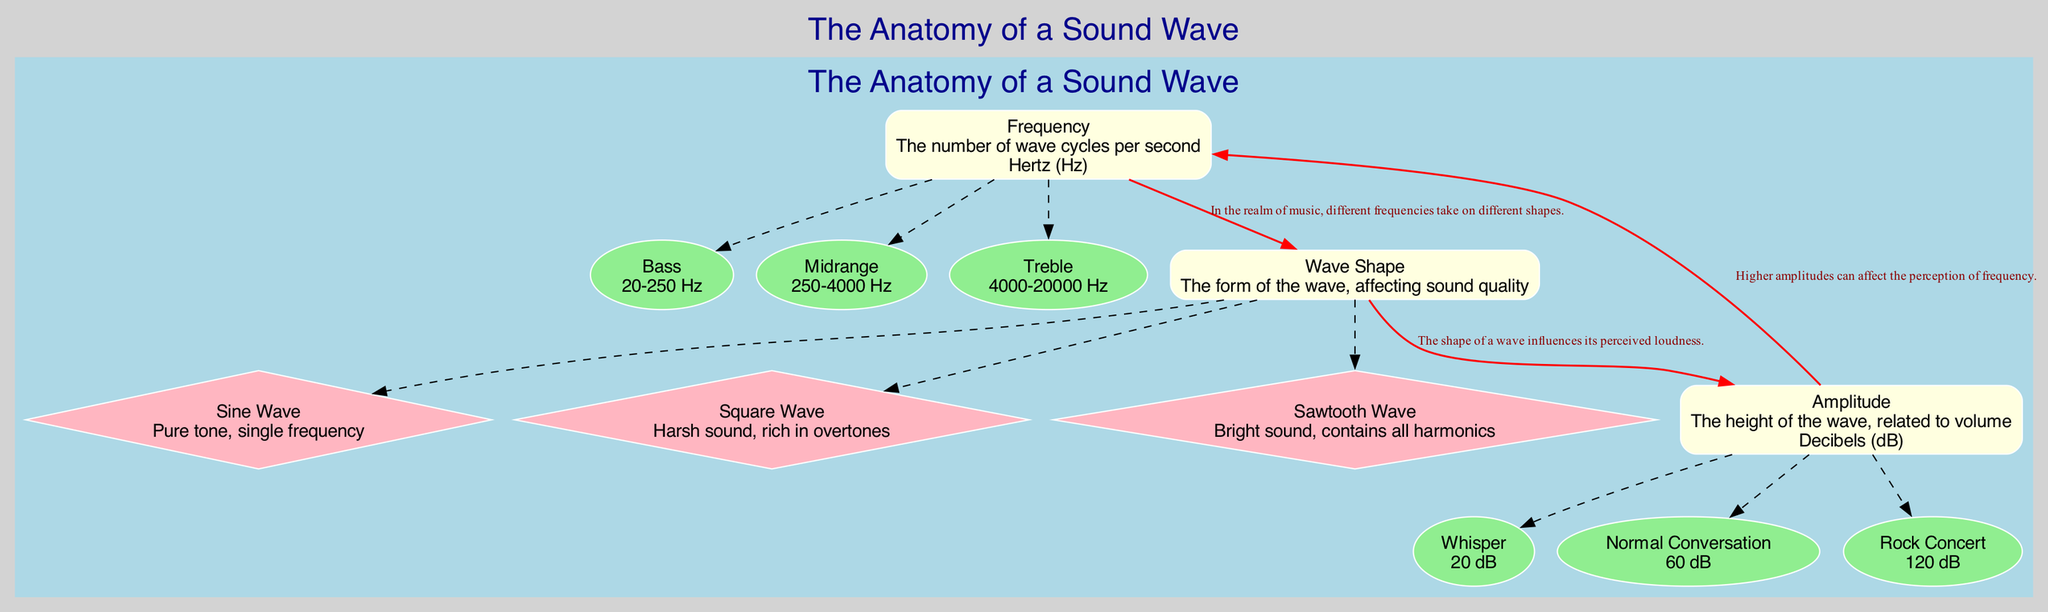What is the unit for frequency? The diagram indicates that frequency is measured in Hertz (Hz). It is clearly stated within the "Frequency" node description in the diagram.
Answer: Hertz (Hz) What is the amplitude of a rock concert? The diagram shows that a rock concert has an amplitude of 120 decibels (dB), as indicated in the "Examples" section under "Amplitude."
Answer: 120 dB How many types of wave shapes are listed? The diagram specifies three types of wave shapes: Sine Wave, Square Wave, and Sawtooth Wave. This information is presented under the "Wave Shape" component in the diagram.
Answer: Three What relationship is indicated between frequency and wave shape? The diagram describes that different frequencies take on different shapes, indicating a relationship of transformation between frequency and wave shape. This is clearly labeled within the edge connecting the two nodes.
Answer: Different shapes Which sound wave type is characterized as a pure tone? The diagram specifies that a Sine Wave is characterized as a pure tone with a single frequency. This detail is included in the description of the Sine Wave under the "Wave Shape" section.
Answer: Sine Wave How many examples of amplitude are provided? There are three examples of amplitude given: Whisper, Normal Conversation, and Rock Concert. This information is outlined under the "Examples" of the "Amplitude" node in the diagram.
Answer: Three What effect does wave shape have on perceived loudness? The diagram indicates that the shape of a wave influences its perceived loudness, demonstrating a relationship between Wave Shape and Amplitude. This connection is detailed in the edge linking these two nodes.
Answer: Influences loudness What is the decibel level of a normal conversation? The diagram states that a normal conversation has an amplitude of 60 decibels (dB), which is indicated in the examples section under "Amplitude."
Answer: 60 dB 